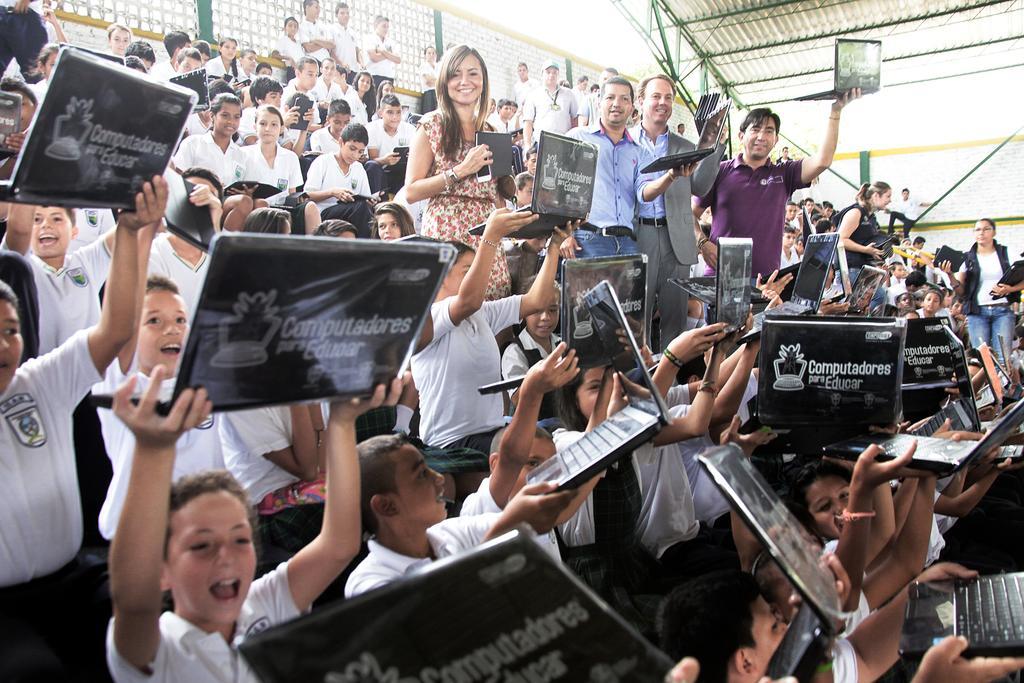Can you describe this image briefly? In this picture, we see children are sitting. Most of them are holding the laptops and the tablets in their hands. In the middle of the picture, we see six people are standing and all of them are holding the laptops. In the background, we see the boys are standing. Behind them, we see the fence. At the top, we see the roof. 